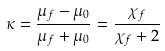Convert formula to latex. <formula><loc_0><loc_0><loc_500><loc_500>\kappa = \frac { \mu _ { f } - \mu _ { 0 } } { \mu _ { f } + \mu _ { 0 } } = \frac { \chi _ { f } } { \chi _ { f } + 2 }</formula> 